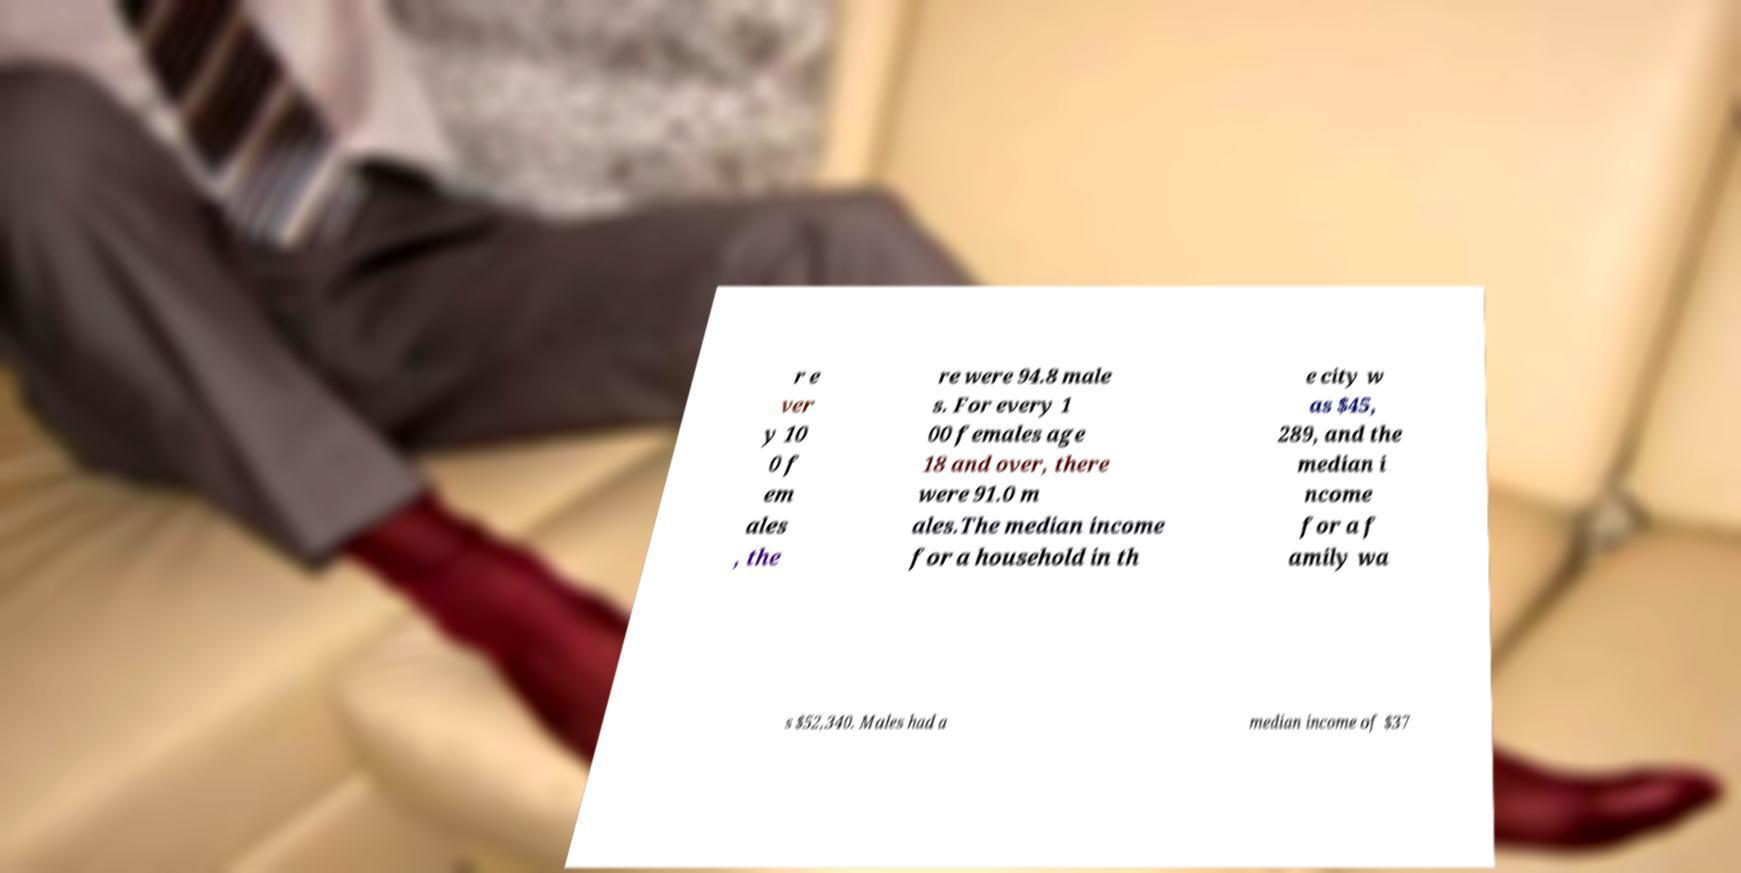There's text embedded in this image that I need extracted. Can you transcribe it verbatim? r e ver y 10 0 f em ales , the re were 94.8 male s. For every 1 00 females age 18 and over, there were 91.0 m ales.The median income for a household in th e city w as $45, 289, and the median i ncome for a f amily wa s $52,340. Males had a median income of $37 